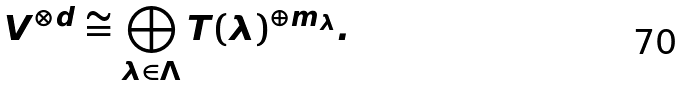<formula> <loc_0><loc_0><loc_500><loc_500>V ^ { \otimes d } \cong \bigoplus _ { \lambda \in \Lambda } T ( \lambda ) ^ { \oplus m _ { \lambda } } .</formula> 